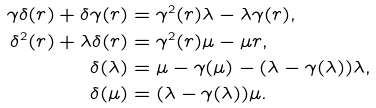Convert formula to latex. <formula><loc_0><loc_0><loc_500><loc_500>\gamma \delta ( r ) + \delta \gamma ( r ) & = \gamma ^ { 2 } ( r ) \lambda - \lambda \gamma ( r ) , \\ \delta ^ { 2 } ( r ) + \lambda \delta ( r ) & = \gamma ^ { 2 } ( r ) \mu - \mu r , \\ \delta ( \lambda ) & = \mu - \gamma ( \mu ) - ( \lambda - \gamma ( \lambda ) ) \lambda , \\ \delta ( \mu ) & = ( \lambda - \gamma ( \lambda ) ) \mu .</formula> 